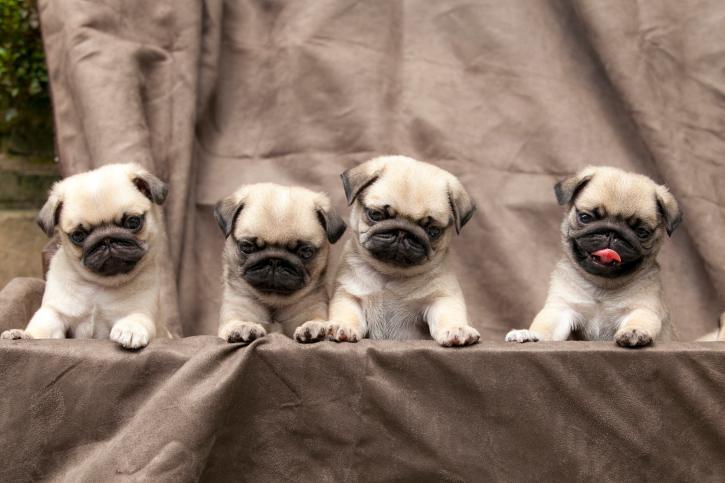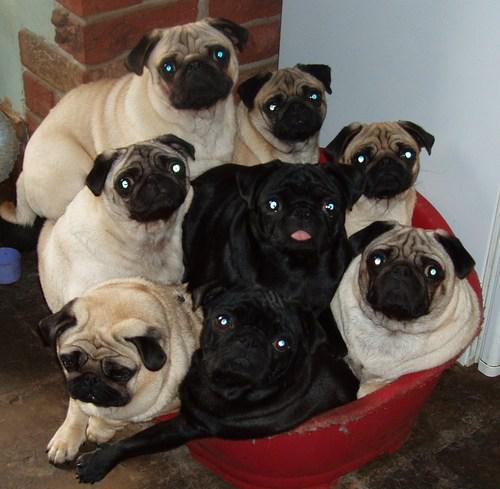The first image is the image on the left, the second image is the image on the right. Considering the images on both sides, is "In one of the images, you will find only one dog." valid? Answer yes or no. No. The first image is the image on the left, the second image is the image on the right. Analyze the images presented: Is the assertion "There are exactly six tan and black nosed pugs along side two predominately black dogs." valid? Answer yes or no. Yes. 